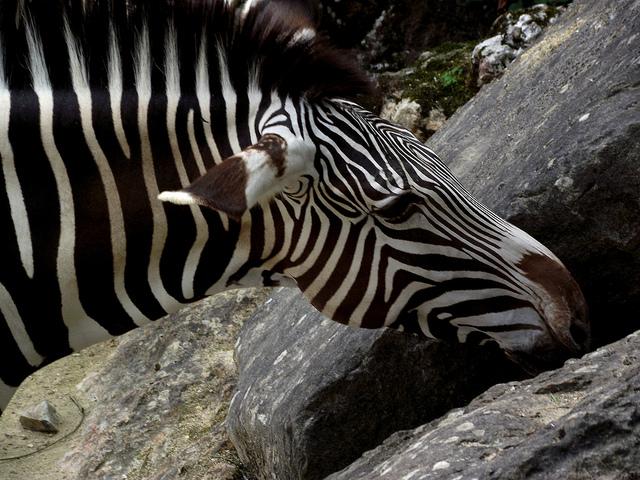Is this a young zebra?
Keep it brief. Yes. What things are in the background?
Answer briefly. Rocks. Does this zebra have its tongue sticking out?
Concise answer only. No. 